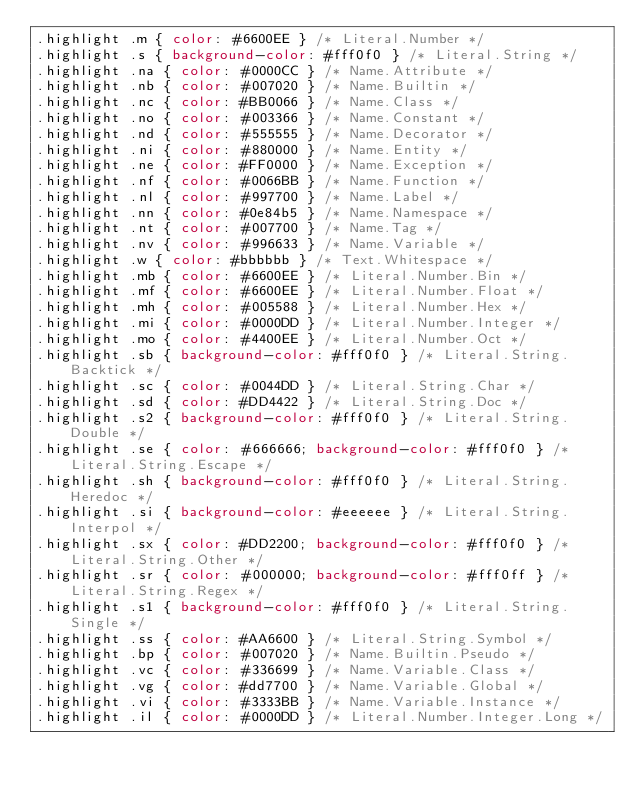Convert code to text. <code><loc_0><loc_0><loc_500><loc_500><_CSS_>.highlight .m { color: #6600EE } /* Literal.Number */
.highlight .s { background-color: #fff0f0 } /* Literal.String */
.highlight .na { color: #0000CC } /* Name.Attribute */
.highlight .nb { color: #007020 } /* Name.Builtin */
.highlight .nc { color: #BB0066 } /* Name.Class */
.highlight .no { color: #003366 } /* Name.Constant */
.highlight .nd { color: #555555 } /* Name.Decorator */
.highlight .ni { color: #880000 } /* Name.Entity */
.highlight .ne { color: #FF0000 } /* Name.Exception */
.highlight .nf { color: #0066BB } /* Name.Function */
.highlight .nl { color: #997700 } /* Name.Label */
.highlight .nn { color: #0e84b5 } /* Name.Namespace */
.highlight .nt { color: #007700 } /* Name.Tag */
.highlight .nv { color: #996633 } /* Name.Variable */
.highlight .w { color: #bbbbbb } /* Text.Whitespace */
.highlight .mb { color: #6600EE } /* Literal.Number.Bin */
.highlight .mf { color: #6600EE } /* Literal.Number.Float */
.highlight .mh { color: #005588 } /* Literal.Number.Hex */
.highlight .mi { color: #0000DD } /* Literal.Number.Integer */
.highlight .mo { color: #4400EE } /* Literal.Number.Oct */
.highlight .sb { background-color: #fff0f0 } /* Literal.String.Backtick */
.highlight .sc { color: #0044DD } /* Literal.String.Char */
.highlight .sd { color: #DD4422 } /* Literal.String.Doc */
.highlight .s2 { background-color: #fff0f0 } /* Literal.String.Double */
.highlight .se { color: #666666; background-color: #fff0f0 } /* Literal.String.Escape */
.highlight .sh { background-color: #fff0f0 } /* Literal.String.Heredoc */
.highlight .si { background-color: #eeeeee } /* Literal.String.Interpol */
.highlight .sx { color: #DD2200; background-color: #fff0f0 } /* Literal.String.Other */
.highlight .sr { color: #000000; background-color: #fff0ff } /* Literal.String.Regex */
.highlight .s1 { background-color: #fff0f0 } /* Literal.String.Single */
.highlight .ss { color: #AA6600 } /* Literal.String.Symbol */
.highlight .bp { color: #007020 } /* Name.Builtin.Pseudo */
.highlight .vc { color: #336699 } /* Name.Variable.Class */
.highlight .vg { color: #dd7700 } /* Name.Variable.Global */
.highlight .vi { color: #3333BB } /* Name.Variable.Instance */
.highlight .il { color: #0000DD } /* Literal.Number.Integer.Long */
</code> 